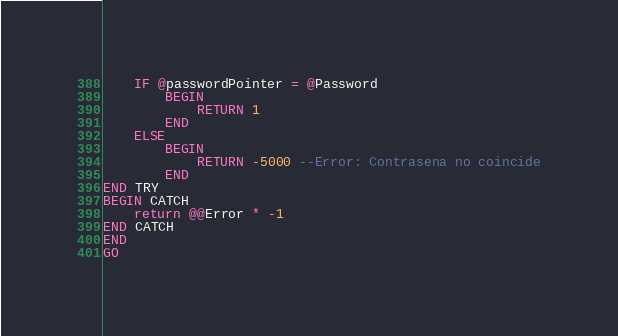Convert code to text. <code><loc_0><loc_0><loc_500><loc_500><_SQL_>	IF @passwordPointer = @Password 
		BEGIN
			RETURN 1
		END
	ELSE
		BEGIN
			RETURN -5000 --Error: Contrasena no coincide
		END
END TRY
BEGIN CATCH
	return @@Error * -1
END CATCH
END
GO</code> 